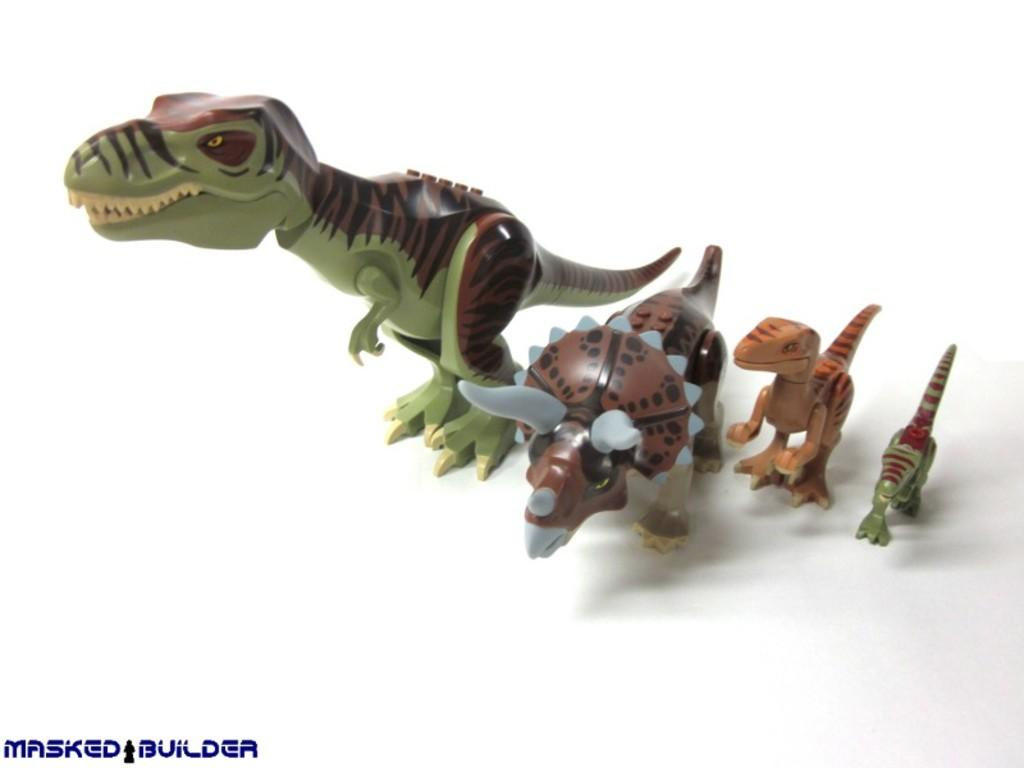What type of objects can be seen in the image? There are toys in the image. What is the owner of the toys attempting to do in the image? There is no owner or attempt present in the image; it only shows toys. 